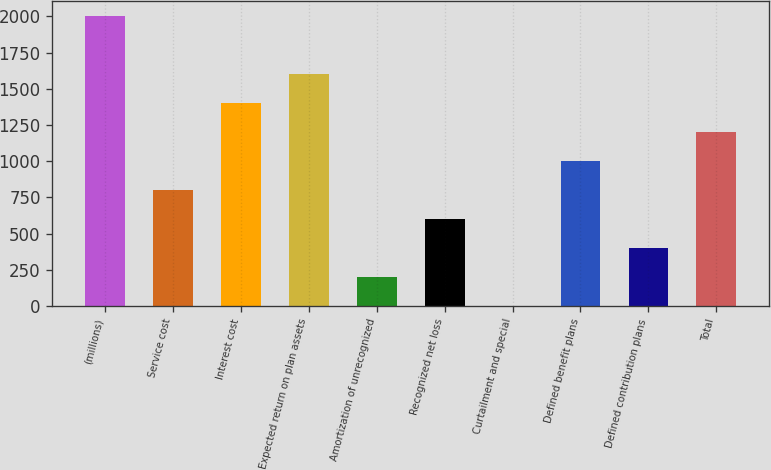Convert chart to OTSL. <chart><loc_0><loc_0><loc_500><loc_500><bar_chart><fcel>(millions)<fcel>Service cost<fcel>Interest cost<fcel>Expected return on plan assets<fcel>Amortization of unrecognized<fcel>Recognized net loss<fcel>Curtailment and special<fcel>Defined benefit plans<fcel>Defined contribution plans<fcel>Total<nl><fcel>2005<fcel>802.96<fcel>1403.98<fcel>1604.32<fcel>201.94<fcel>602.62<fcel>1.6<fcel>1003.3<fcel>402.28<fcel>1203.64<nl></chart> 